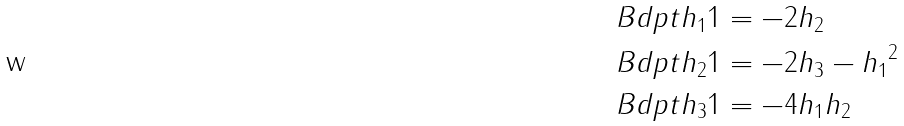<formula> <loc_0><loc_0><loc_500><loc_500>\ B d p t { h _ { 1 } } 1 & = - 2 h _ { 2 } \\ \ B d p t { h _ { 2 } } 1 & = - 2 h _ { 3 } - { h _ { 1 } } ^ { 2 } \\ \ B d p t { h _ { 3 } } 1 & = - 4 h _ { 1 } h _ { 2 } \\</formula> 